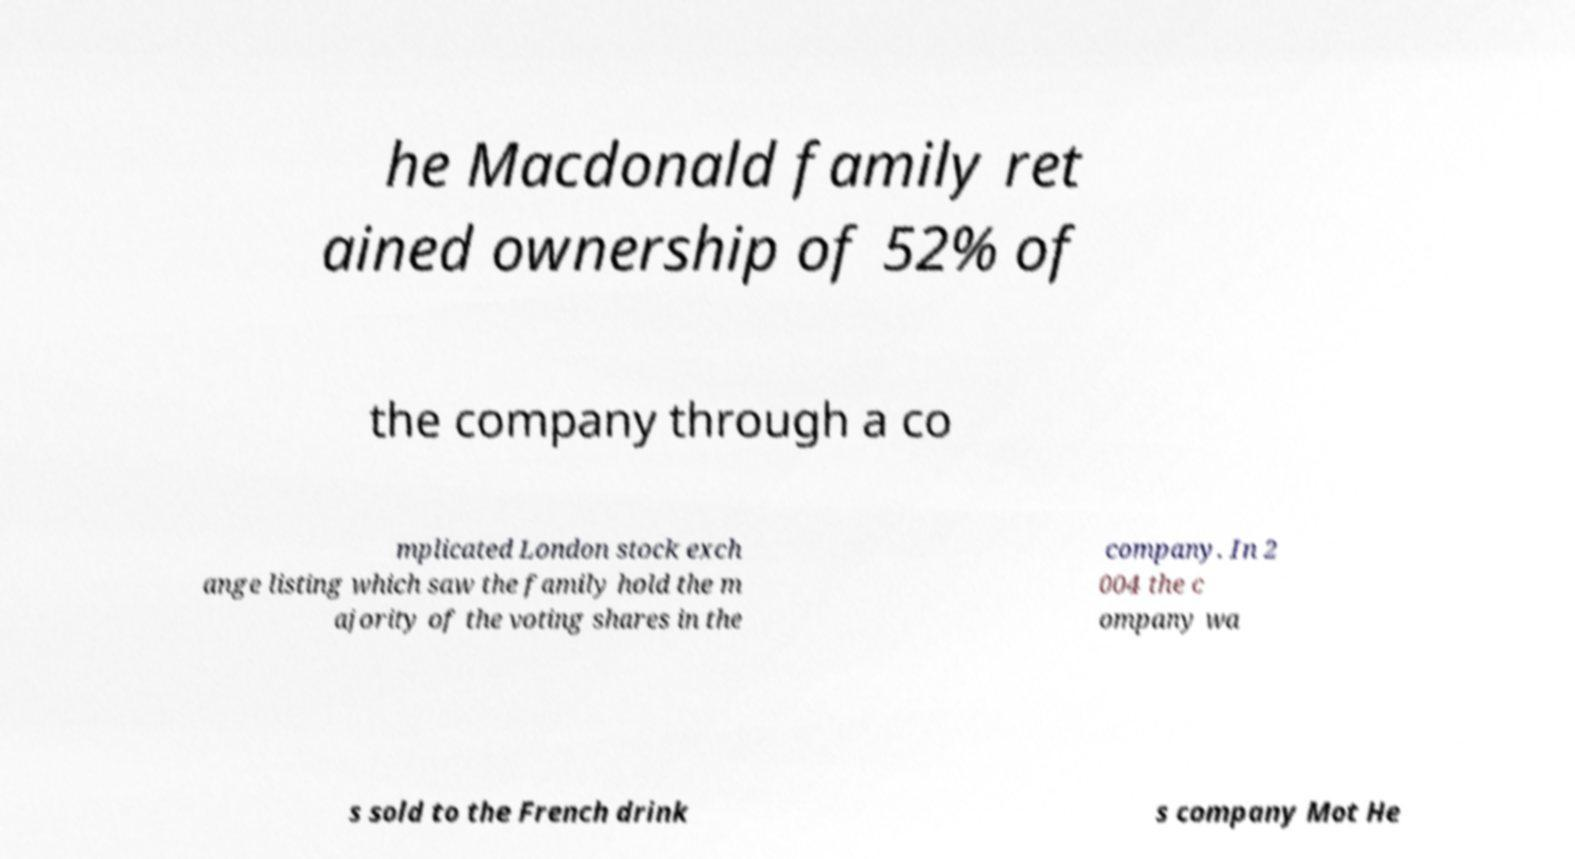Could you assist in decoding the text presented in this image and type it out clearly? he Macdonald family ret ained ownership of 52% of the company through a co mplicated London stock exch ange listing which saw the family hold the m ajority of the voting shares in the company. In 2 004 the c ompany wa s sold to the French drink s company Mot He 